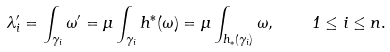Convert formula to latex. <formula><loc_0><loc_0><loc_500><loc_500>\lambda _ { i } ^ { \prime } = \int _ { \gamma _ { i } } \omega ^ { \prime } = \mu \int _ { \gamma _ { i } } h ^ { * } ( \omega ) = \mu \int _ { h _ { * } ( \gamma _ { i } ) } \omega , \quad 1 \leq i \leq n .</formula> 